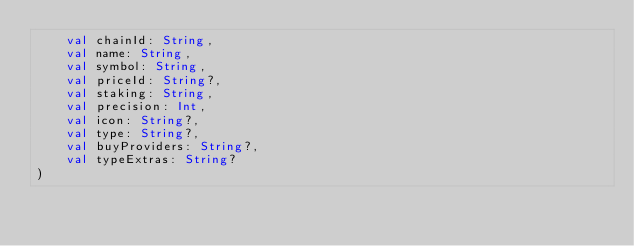<code> <loc_0><loc_0><loc_500><loc_500><_Kotlin_>    val chainId: String,
    val name: String,
    val symbol: String,
    val priceId: String?,
    val staking: String,
    val precision: Int,
    val icon: String?,
    val type: String?,
    val buyProviders: String?,
    val typeExtras: String?
)
</code> 